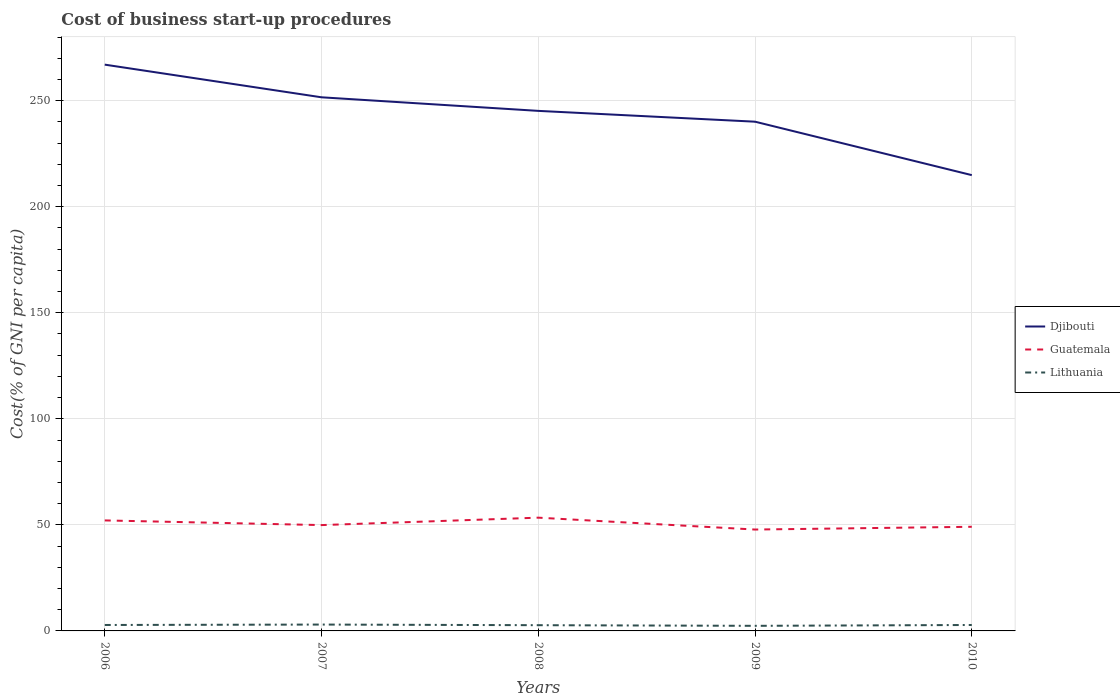How many different coloured lines are there?
Offer a very short reply. 3. Across all years, what is the maximum cost of business start-up procedures in Djibouti?
Provide a succinct answer. 214.9. In which year was the cost of business start-up procedures in Lithuania maximum?
Keep it short and to the point. 2009. What is the total cost of business start-up procedures in Djibouti in the graph?
Make the answer very short. 25.2. What is the difference between the highest and the second highest cost of business start-up procedures in Djibouti?
Your answer should be compact. 52.1. How many lines are there?
Ensure brevity in your answer.  3. Does the graph contain any zero values?
Your answer should be very brief. No. Does the graph contain grids?
Offer a terse response. Yes. What is the title of the graph?
Your response must be concise. Cost of business start-up procedures. What is the label or title of the Y-axis?
Your answer should be very brief. Cost(% of GNI per capita). What is the Cost(% of GNI per capita) in Djibouti in 2006?
Make the answer very short. 267. What is the Cost(% of GNI per capita) in Guatemala in 2006?
Keep it short and to the point. 52.1. What is the Cost(% of GNI per capita) of Lithuania in 2006?
Your response must be concise. 2.8. What is the Cost(% of GNI per capita) in Djibouti in 2007?
Ensure brevity in your answer.  251.6. What is the Cost(% of GNI per capita) of Guatemala in 2007?
Offer a very short reply. 49.9. What is the Cost(% of GNI per capita) in Lithuania in 2007?
Offer a terse response. 3. What is the Cost(% of GNI per capita) in Djibouti in 2008?
Provide a succinct answer. 245.2. What is the Cost(% of GNI per capita) in Guatemala in 2008?
Provide a short and direct response. 53.4. What is the Cost(% of GNI per capita) in Djibouti in 2009?
Make the answer very short. 240.1. What is the Cost(% of GNI per capita) of Guatemala in 2009?
Make the answer very short. 47.8. What is the Cost(% of GNI per capita) in Djibouti in 2010?
Offer a very short reply. 214.9. What is the Cost(% of GNI per capita) in Guatemala in 2010?
Your response must be concise. 49.1. Across all years, what is the maximum Cost(% of GNI per capita) in Djibouti?
Offer a terse response. 267. Across all years, what is the maximum Cost(% of GNI per capita) in Guatemala?
Offer a very short reply. 53.4. Across all years, what is the maximum Cost(% of GNI per capita) of Lithuania?
Offer a very short reply. 3. Across all years, what is the minimum Cost(% of GNI per capita) of Djibouti?
Provide a short and direct response. 214.9. Across all years, what is the minimum Cost(% of GNI per capita) in Guatemala?
Make the answer very short. 47.8. What is the total Cost(% of GNI per capita) in Djibouti in the graph?
Keep it short and to the point. 1218.8. What is the total Cost(% of GNI per capita) in Guatemala in the graph?
Offer a terse response. 252.3. What is the total Cost(% of GNI per capita) in Lithuania in the graph?
Offer a terse response. 13.7. What is the difference between the Cost(% of GNI per capita) of Djibouti in 2006 and that in 2007?
Your answer should be compact. 15.4. What is the difference between the Cost(% of GNI per capita) of Guatemala in 2006 and that in 2007?
Provide a succinct answer. 2.2. What is the difference between the Cost(% of GNI per capita) of Lithuania in 2006 and that in 2007?
Give a very brief answer. -0.2. What is the difference between the Cost(% of GNI per capita) in Djibouti in 2006 and that in 2008?
Keep it short and to the point. 21.8. What is the difference between the Cost(% of GNI per capita) in Guatemala in 2006 and that in 2008?
Provide a succinct answer. -1.3. What is the difference between the Cost(% of GNI per capita) of Lithuania in 2006 and that in 2008?
Offer a very short reply. 0.1. What is the difference between the Cost(% of GNI per capita) of Djibouti in 2006 and that in 2009?
Your answer should be compact. 26.9. What is the difference between the Cost(% of GNI per capita) of Lithuania in 2006 and that in 2009?
Offer a very short reply. 0.4. What is the difference between the Cost(% of GNI per capita) of Djibouti in 2006 and that in 2010?
Your response must be concise. 52.1. What is the difference between the Cost(% of GNI per capita) in Djibouti in 2007 and that in 2008?
Provide a short and direct response. 6.4. What is the difference between the Cost(% of GNI per capita) in Guatemala in 2007 and that in 2008?
Your response must be concise. -3.5. What is the difference between the Cost(% of GNI per capita) of Lithuania in 2007 and that in 2008?
Ensure brevity in your answer.  0.3. What is the difference between the Cost(% of GNI per capita) of Guatemala in 2007 and that in 2009?
Keep it short and to the point. 2.1. What is the difference between the Cost(% of GNI per capita) in Djibouti in 2007 and that in 2010?
Offer a terse response. 36.7. What is the difference between the Cost(% of GNI per capita) in Guatemala in 2007 and that in 2010?
Give a very brief answer. 0.8. What is the difference between the Cost(% of GNI per capita) in Djibouti in 2008 and that in 2009?
Give a very brief answer. 5.1. What is the difference between the Cost(% of GNI per capita) of Guatemala in 2008 and that in 2009?
Your response must be concise. 5.6. What is the difference between the Cost(% of GNI per capita) in Lithuania in 2008 and that in 2009?
Provide a short and direct response. 0.3. What is the difference between the Cost(% of GNI per capita) of Djibouti in 2008 and that in 2010?
Ensure brevity in your answer.  30.3. What is the difference between the Cost(% of GNI per capita) in Guatemala in 2008 and that in 2010?
Give a very brief answer. 4.3. What is the difference between the Cost(% of GNI per capita) of Lithuania in 2008 and that in 2010?
Provide a short and direct response. -0.1. What is the difference between the Cost(% of GNI per capita) of Djibouti in 2009 and that in 2010?
Ensure brevity in your answer.  25.2. What is the difference between the Cost(% of GNI per capita) of Guatemala in 2009 and that in 2010?
Offer a very short reply. -1.3. What is the difference between the Cost(% of GNI per capita) in Djibouti in 2006 and the Cost(% of GNI per capita) in Guatemala in 2007?
Make the answer very short. 217.1. What is the difference between the Cost(% of GNI per capita) in Djibouti in 2006 and the Cost(% of GNI per capita) in Lithuania in 2007?
Your response must be concise. 264. What is the difference between the Cost(% of GNI per capita) of Guatemala in 2006 and the Cost(% of GNI per capita) of Lithuania in 2007?
Make the answer very short. 49.1. What is the difference between the Cost(% of GNI per capita) in Djibouti in 2006 and the Cost(% of GNI per capita) in Guatemala in 2008?
Your response must be concise. 213.6. What is the difference between the Cost(% of GNI per capita) in Djibouti in 2006 and the Cost(% of GNI per capita) in Lithuania in 2008?
Your answer should be compact. 264.3. What is the difference between the Cost(% of GNI per capita) in Guatemala in 2006 and the Cost(% of GNI per capita) in Lithuania in 2008?
Your response must be concise. 49.4. What is the difference between the Cost(% of GNI per capita) in Djibouti in 2006 and the Cost(% of GNI per capita) in Guatemala in 2009?
Make the answer very short. 219.2. What is the difference between the Cost(% of GNI per capita) in Djibouti in 2006 and the Cost(% of GNI per capita) in Lithuania in 2009?
Make the answer very short. 264.6. What is the difference between the Cost(% of GNI per capita) of Guatemala in 2006 and the Cost(% of GNI per capita) of Lithuania in 2009?
Give a very brief answer. 49.7. What is the difference between the Cost(% of GNI per capita) of Djibouti in 2006 and the Cost(% of GNI per capita) of Guatemala in 2010?
Make the answer very short. 217.9. What is the difference between the Cost(% of GNI per capita) of Djibouti in 2006 and the Cost(% of GNI per capita) of Lithuania in 2010?
Provide a succinct answer. 264.2. What is the difference between the Cost(% of GNI per capita) in Guatemala in 2006 and the Cost(% of GNI per capita) in Lithuania in 2010?
Provide a succinct answer. 49.3. What is the difference between the Cost(% of GNI per capita) of Djibouti in 2007 and the Cost(% of GNI per capita) of Guatemala in 2008?
Your answer should be very brief. 198.2. What is the difference between the Cost(% of GNI per capita) in Djibouti in 2007 and the Cost(% of GNI per capita) in Lithuania in 2008?
Offer a very short reply. 248.9. What is the difference between the Cost(% of GNI per capita) in Guatemala in 2007 and the Cost(% of GNI per capita) in Lithuania in 2008?
Offer a very short reply. 47.2. What is the difference between the Cost(% of GNI per capita) in Djibouti in 2007 and the Cost(% of GNI per capita) in Guatemala in 2009?
Provide a short and direct response. 203.8. What is the difference between the Cost(% of GNI per capita) in Djibouti in 2007 and the Cost(% of GNI per capita) in Lithuania in 2009?
Give a very brief answer. 249.2. What is the difference between the Cost(% of GNI per capita) of Guatemala in 2007 and the Cost(% of GNI per capita) of Lithuania in 2009?
Your response must be concise. 47.5. What is the difference between the Cost(% of GNI per capita) in Djibouti in 2007 and the Cost(% of GNI per capita) in Guatemala in 2010?
Your response must be concise. 202.5. What is the difference between the Cost(% of GNI per capita) of Djibouti in 2007 and the Cost(% of GNI per capita) of Lithuania in 2010?
Your answer should be compact. 248.8. What is the difference between the Cost(% of GNI per capita) of Guatemala in 2007 and the Cost(% of GNI per capita) of Lithuania in 2010?
Keep it short and to the point. 47.1. What is the difference between the Cost(% of GNI per capita) in Djibouti in 2008 and the Cost(% of GNI per capita) in Guatemala in 2009?
Keep it short and to the point. 197.4. What is the difference between the Cost(% of GNI per capita) of Djibouti in 2008 and the Cost(% of GNI per capita) of Lithuania in 2009?
Keep it short and to the point. 242.8. What is the difference between the Cost(% of GNI per capita) in Guatemala in 2008 and the Cost(% of GNI per capita) in Lithuania in 2009?
Your answer should be very brief. 51. What is the difference between the Cost(% of GNI per capita) of Djibouti in 2008 and the Cost(% of GNI per capita) of Guatemala in 2010?
Your response must be concise. 196.1. What is the difference between the Cost(% of GNI per capita) of Djibouti in 2008 and the Cost(% of GNI per capita) of Lithuania in 2010?
Make the answer very short. 242.4. What is the difference between the Cost(% of GNI per capita) in Guatemala in 2008 and the Cost(% of GNI per capita) in Lithuania in 2010?
Offer a very short reply. 50.6. What is the difference between the Cost(% of GNI per capita) in Djibouti in 2009 and the Cost(% of GNI per capita) in Guatemala in 2010?
Ensure brevity in your answer.  191. What is the difference between the Cost(% of GNI per capita) in Djibouti in 2009 and the Cost(% of GNI per capita) in Lithuania in 2010?
Offer a very short reply. 237.3. What is the average Cost(% of GNI per capita) of Djibouti per year?
Provide a short and direct response. 243.76. What is the average Cost(% of GNI per capita) in Guatemala per year?
Ensure brevity in your answer.  50.46. What is the average Cost(% of GNI per capita) of Lithuania per year?
Give a very brief answer. 2.74. In the year 2006, what is the difference between the Cost(% of GNI per capita) of Djibouti and Cost(% of GNI per capita) of Guatemala?
Offer a very short reply. 214.9. In the year 2006, what is the difference between the Cost(% of GNI per capita) in Djibouti and Cost(% of GNI per capita) in Lithuania?
Ensure brevity in your answer.  264.2. In the year 2006, what is the difference between the Cost(% of GNI per capita) of Guatemala and Cost(% of GNI per capita) of Lithuania?
Keep it short and to the point. 49.3. In the year 2007, what is the difference between the Cost(% of GNI per capita) of Djibouti and Cost(% of GNI per capita) of Guatemala?
Provide a succinct answer. 201.7. In the year 2007, what is the difference between the Cost(% of GNI per capita) in Djibouti and Cost(% of GNI per capita) in Lithuania?
Keep it short and to the point. 248.6. In the year 2007, what is the difference between the Cost(% of GNI per capita) in Guatemala and Cost(% of GNI per capita) in Lithuania?
Provide a short and direct response. 46.9. In the year 2008, what is the difference between the Cost(% of GNI per capita) of Djibouti and Cost(% of GNI per capita) of Guatemala?
Offer a very short reply. 191.8. In the year 2008, what is the difference between the Cost(% of GNI per capita) of Djibouti and Cost(% of GNI per capita) of Lithuania?
Give a very brief answer. 242.5. In the year 2008, what is the difference between the Cost(% of GNI per capita) of Guatemala and Cost(% of GNI per capita) of Lithuania?
Provide a succinct answer. 50.7. In the year 2009, what is the difference between the Cost(% of GNI per capita) in Djibouti and Cost(% of GNI per capita) in Guatemala?
Keep it short and to the point. 192.3. In the year 2009, what is the difference between the Cost(% of GNI per capita) of Djibouti and Cost(% of GNI per capita) of Lithuania?
Offer a very short reply. 237.7. In the year 2009, what is the difference between the Cost(% of GNI per capita) in Guatemala and Cost(% of GNI per capita) in Lithuania?
Give a very brief answer. 45.4. In the year 2010, what is the difference between the Cost(% of GNI per capita) in Djibouti and Cost(% of GNI per capita) in Guatemala?
Keep it short and to the point. 165.8. In the year 2010, what is the difference between the Cost(% of GNI per capita) in Djibouti and Cost(% of GNI per capita) in Lithuania?
Give a very brief answer. 212.1. In the year 2010, what is the difference between the Cost(% of GNI per capita) in Guatemala and Cost(% of GNI per capita) in Lithuania?
Your response must be concise. 46.3. What is the ratio of the Cost(% of GNI per capita) of Djibouti in 2006 to that in 2007?
Keep it short and to the point. 1.06. What is the ratio of the Cost(% of GNI per capita) of Guatemala in 2006 to that in 2007?
Provide a succinct answer. 1.04. What is the ratio of the Cost(% of GNI per capita) in Djibouti in 2006 to that in 2008?
Keep it short and to the point. 1.09. What is the ratio of the Cost(% of GNI per capita) of Guatemala in 2006 to that in 2008?
Your answer should be very brief. 0.98. What is the ratio of the Cost(% of GNI per capita) in Lithuania in 2006 to that in 2008?
Keep it short and to the point. 1.04. What is the ratio of the Cost(% of GNI per capita) of Djibouti in 2006 to that in 2009?
Ensure brevity in your answer.  1.11. What is the ratio of the Cost(% of GNI per capita) in Guatemala in 2006 to that in 2009?
Offer a terse response. 1.09. What is the ratio of the Cost(% of GNI per capita) of Lithuania in 2006 to that in 2009?
Your answer should be compact. 1.17. What is the ratio of the Cost(% of GNI per capita) of Djibouti in 2006 to that in 2010?
Your answer should be very brief. 1.24. What is the ratio of the Cost(% of GNI per capita) in Guatemala in 2006 to that in 2010?
Keep it short and to the point. 1.06. What is the ratio of the Cost(% of GNI per capita) in Lithuania in 2006 to that in 2010?
Your answer should be compact. 1. What is the ratio of the Cost(% of GNI per capita) of Djibouti in 2007 to that in 2008?
Provide a short and direct response. 1.03. What is the ratio of the Cost(% of GNI per capita) in Guatemala in 2007 to that in 2008?
Ensure brevity in your answer.  0.93. What is the ratio of the Cost(% of GNI per capita) of Lithuania in 2007 to that in 2008?
Provide a succinct answer. 1.11. What is the ratio of the Cost(% of GNI per capita) in Djibouti in 2007 to that in 2009?
Make the answer very short. 1.05. What is the ratio of the Cost(% of GNI per capita) in Guatemala in 2007 to that in 2009?
Your answer should be very brief. 1.04. What is the ratio of the Cost(% of GNI per capita) in Lithuania in 2007 to that in 2009?
Your answer should be compact. 1.25. What is the ratio of the Cost(% of GNI per capita) in Djibouti in 2007 to that in 2010?
Your answer should be very brief. 1.17. What is the ratio of the Cost(% of GNI per capita) in Guatemala in 2007 to that in 2010?
Provide a short and direct response. 1.02. What is the ratio of the Cost(% of GNI per capita) of Lithuania in 2007 to that in 2010?
Give a very brief answer. 1.07. What is the ratio of the Cost(% of GNI per capita) of Djibouti in 2008 to that in 2009?
Your answer should be very brief. 1.02. What is the ratio of the Cost(% of GNI per capita) of Guatemala in 2008 to that in 2009?
Your answer should be very brief. 1.12. What is the ratio of the Cost(% of GNI per capita) of Djibouti in 2008 to that in 2010?
Provide a succinct answer. 1.14. What is the ratio of the Cost(% of GNI per capita) of Guatemala in 2008 to that in 2010?
Your response must be concise. 1.09. What is the ratio of the Cost(% of GNI per capita) in Lithuania in 2008 to that in 2010?
Provide a succinct answer. 0.96. What is the ratio of the Cost(% of GNI per capita) of Djibouti in 2009 to that in 2010?
Provide a succinct answer. 1.12. What is the ratio of the Cost(% of GNI per capita) of Guatemala in 2009 to that in 2010?
Keep it short and to the point. 0.97. What is the difference between the highest and the second highest Cost(% of GNI per capita) in Guatemala?
Offer a very short reply. 1.3. What is the difference between the highest and the lowest Cost(% of GNI per capita) of Djibouti?
Give a very brief answer. 52.1. What is the difference between the highest and the lowest Cost(% of GNI per capita) of Guatemala?
Keep it short and to the point. 5.6. What is the difference between the highest and the lowest Cost(% of GNI per capita) in Lithuania?
Give a very brief answer. 0.6. 